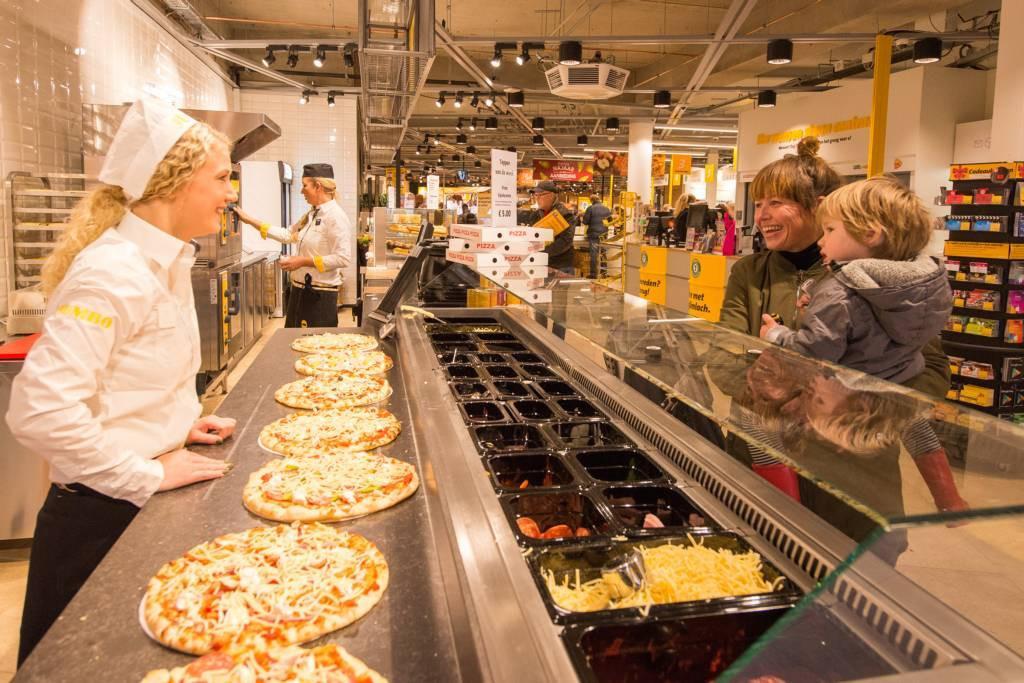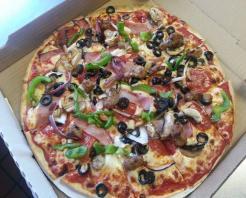The first image is the image on the left, the second image is the image on the right. Examine the images to the left and right. Is the description "A whole pizza sits in a cardboard box in one of the images." accurate? Answer yes or no. Yes. The first image is the image on the left, the second image is the image on the right. Assess this claim about the two images: "There is a single slice of pizza on a paper plate.". Correct or not? Answer yes or no. No. 